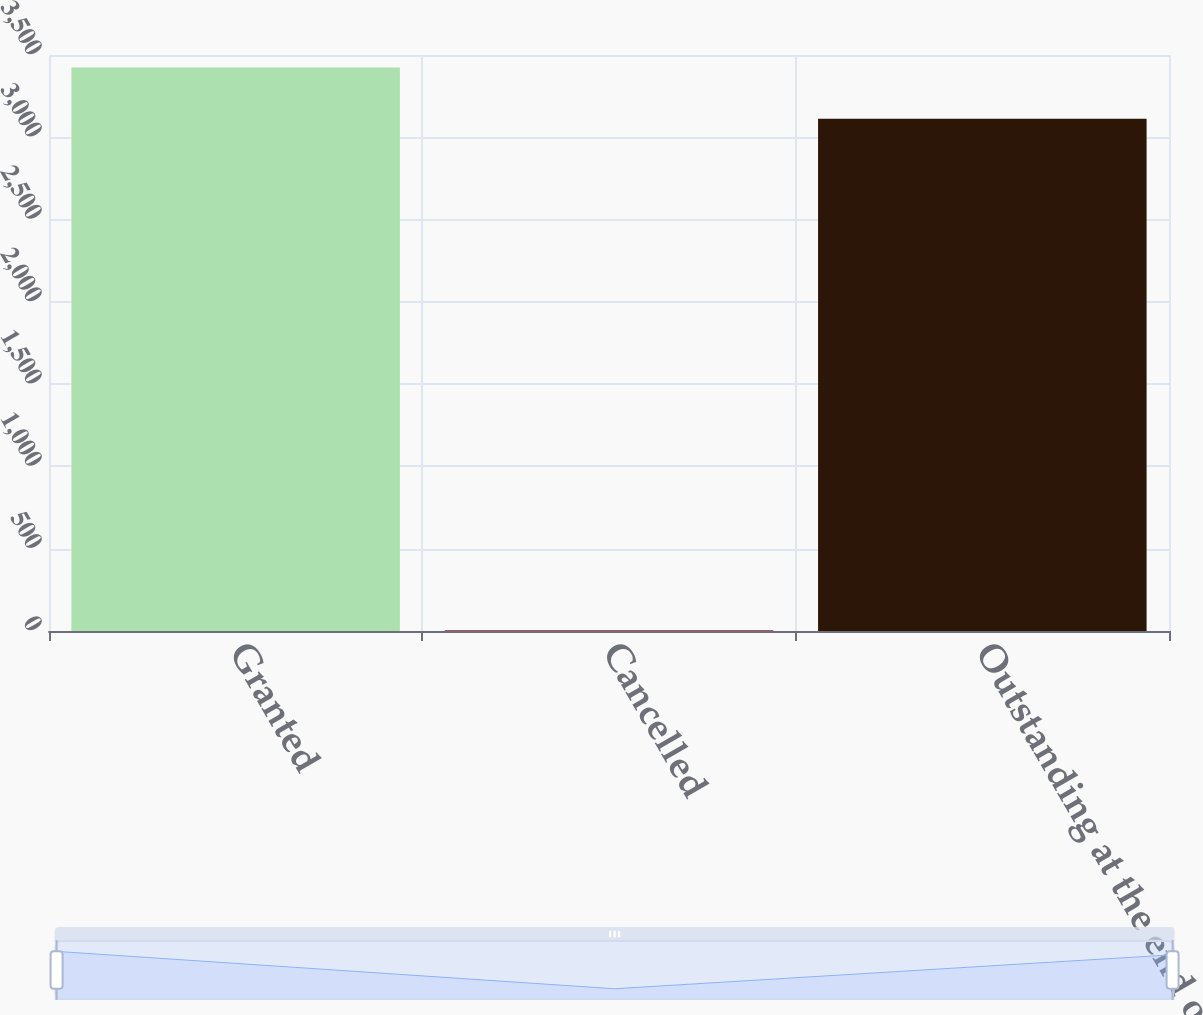Convert chart to OTSL. <chart><loc_0><loc_0><loc_500><loc_500><bar_chart><fcel>Granted<fcel>Cancelled<fcel>Outstanding at the end of the<nl><fcel>3424.3<fcel>5<fcel>3113<nl></chart> 